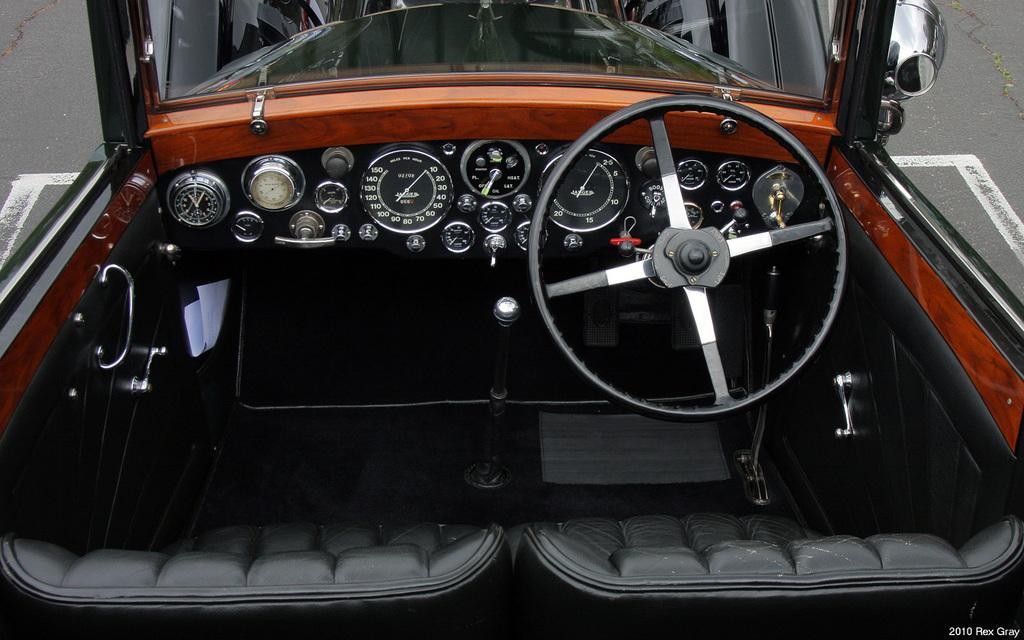In one or two sentences, can you explain what this image depicts? In this image, we can see the interior view of a vehicle. We can also see the ground. 